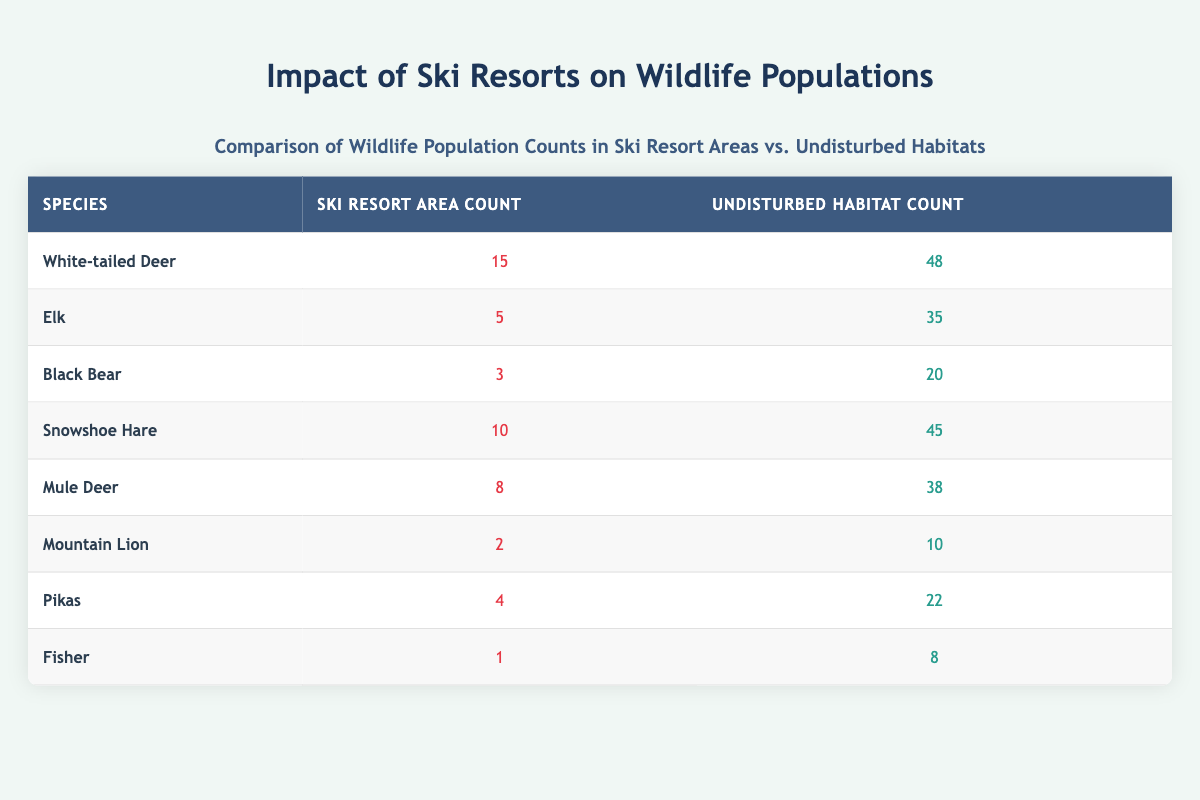What is the population count of White-tailed Deer in ski resort areas? According to the table, the ski resort area count for White-tailed Deer is listed as 15.
Answer: 15 How many more Elk are found in undisturbed habitats than in ski resort areas? The count of Elk in undisturbed habitats is 35, while in ski resort areas, it is 5. Subtracting these gives 35 - 5 = 30 more Elk in undisturbed habitats.
Answer: 30 True or False: The number of Black Bears is greater in ski resort areas than in undisturbed habitats. In ski resort areas, the count for Black Bear is 3, whereas in undisturbed habitats, it is 20. Since 3 is less than 20, the statement is false.
Answer: False Which species has the highest population count in ski resort areas? Looking at the ski resort area counts, White-tailed Deer has the highest count of 15, compared to all other species listed.
Answer: White-tailed Deer What is the combined total population count of Snowshoe Hare and Mule Deer in undisturbed habitats? The count for Snowshoe Hare in undisturbed habitats is 45, and for Mule Deer, it is 38. Adding these gives 45 + 38 = 83 as the combined total.
Answer: 83 How many species have a ski resort area count of less than 5? The species with counts less than 5 in ski resort areas are: Mountain Lion (2), Pikas (4), and Fisher (1), which totals 3 species.
Answer: 3 What percentage of the population of Pikas is present in ski resort areas compared to undisturbed habitats? The count of Pikas in ski resort areas is 4 and in undisturbed habitats is 22. The total Pikas is 4 + 22 = 26. To find the percentage in ski resort areas, (4/26) * 100 = 15.38%.
Answer: 15.38% What is the average wildlife population count for undisturbed habitats across all species listed? The total counts for undisturbed habitats are 48 + 35 + 20 + 45 + 38 + 10 + 22 + 8 = 226. There are 8 species, so the average is 226/8 = 28.25.
Answer: 28.25 